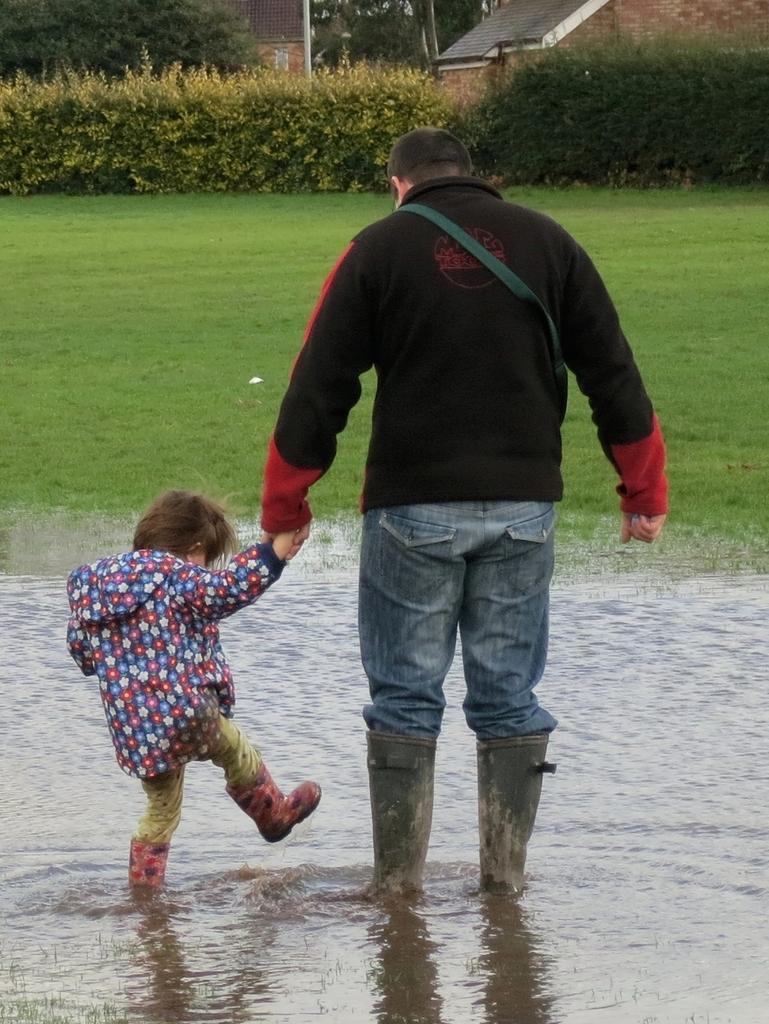Please provide a concise description of this image. In this image we can see a child wearing long boots and a person wearing a black jacket and long boots are standing in the water. Here we can see the grass, shrubs and houses in the background. 